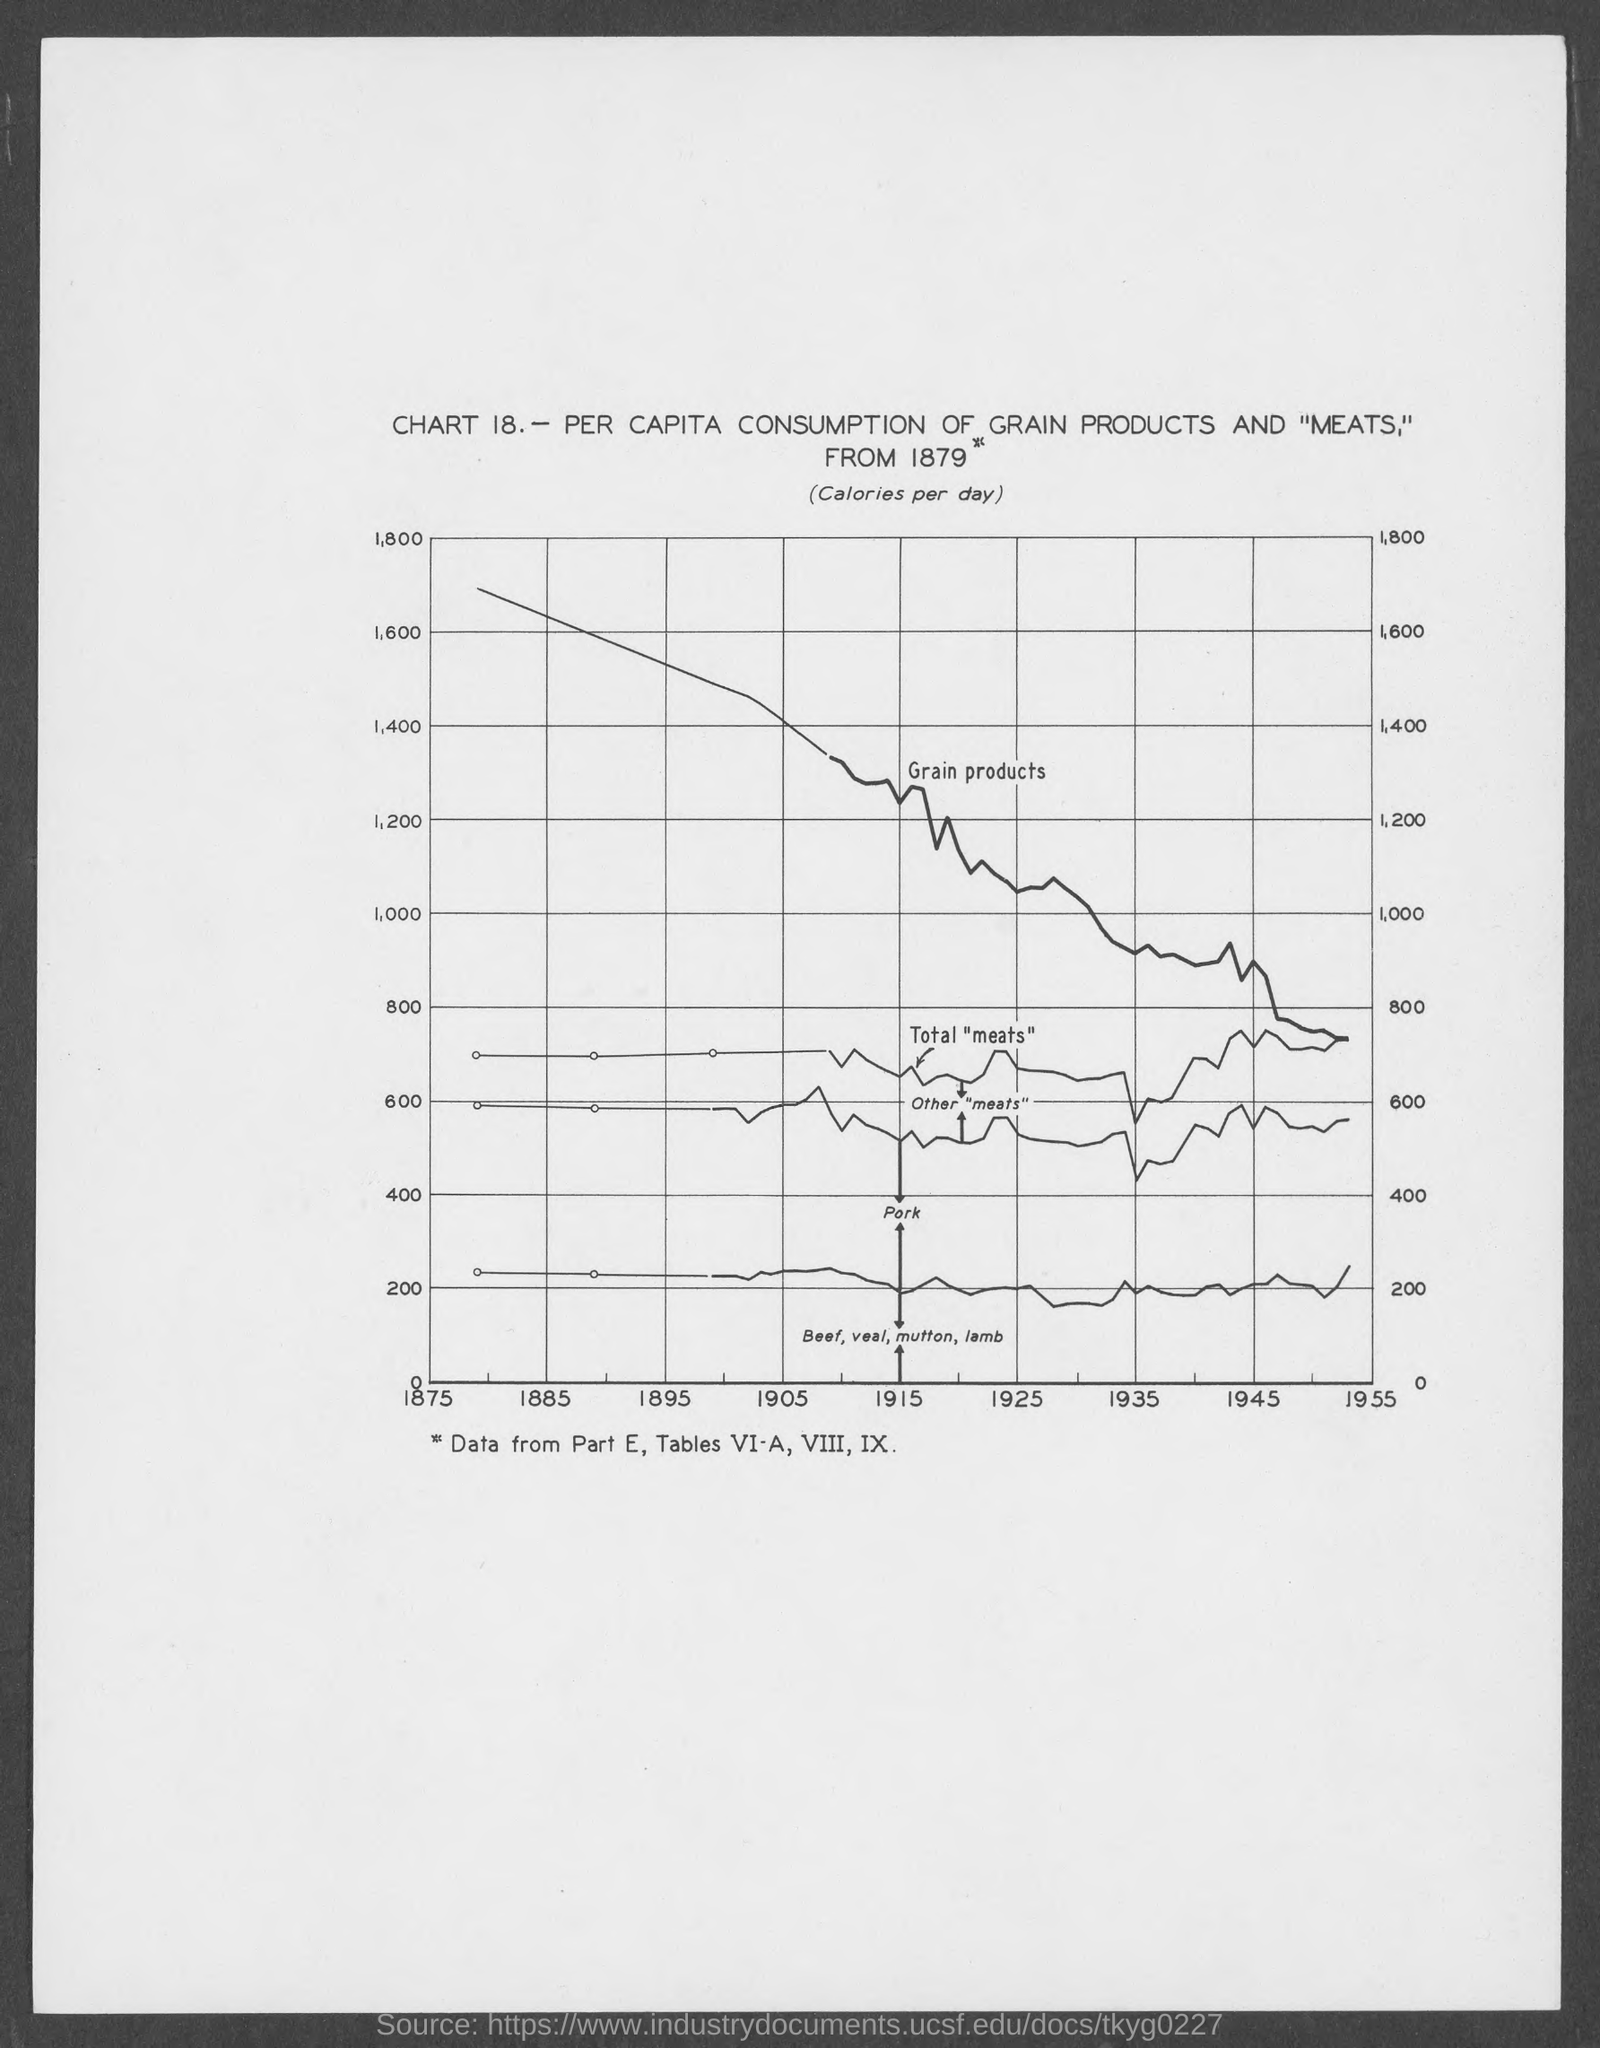What is the chart number?
Your answer should be very brief. 18. What is the part number?
Provide a succinct answer. Part E. 